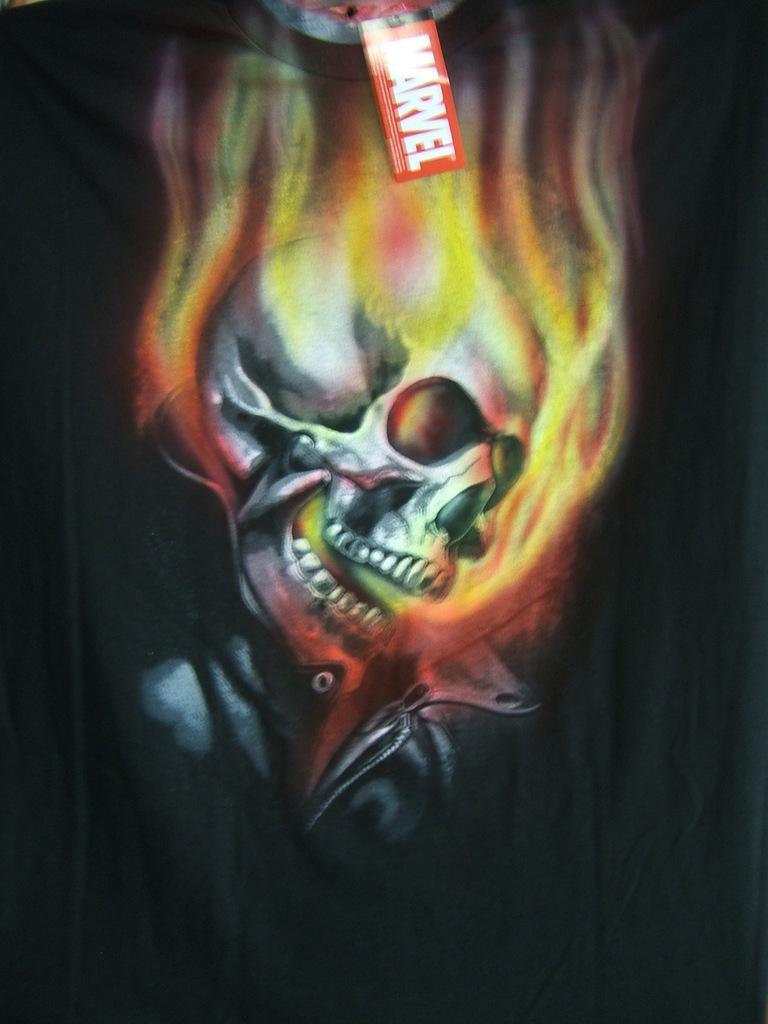Describe this image in one or two sentences. Here, we can see an animated image. 